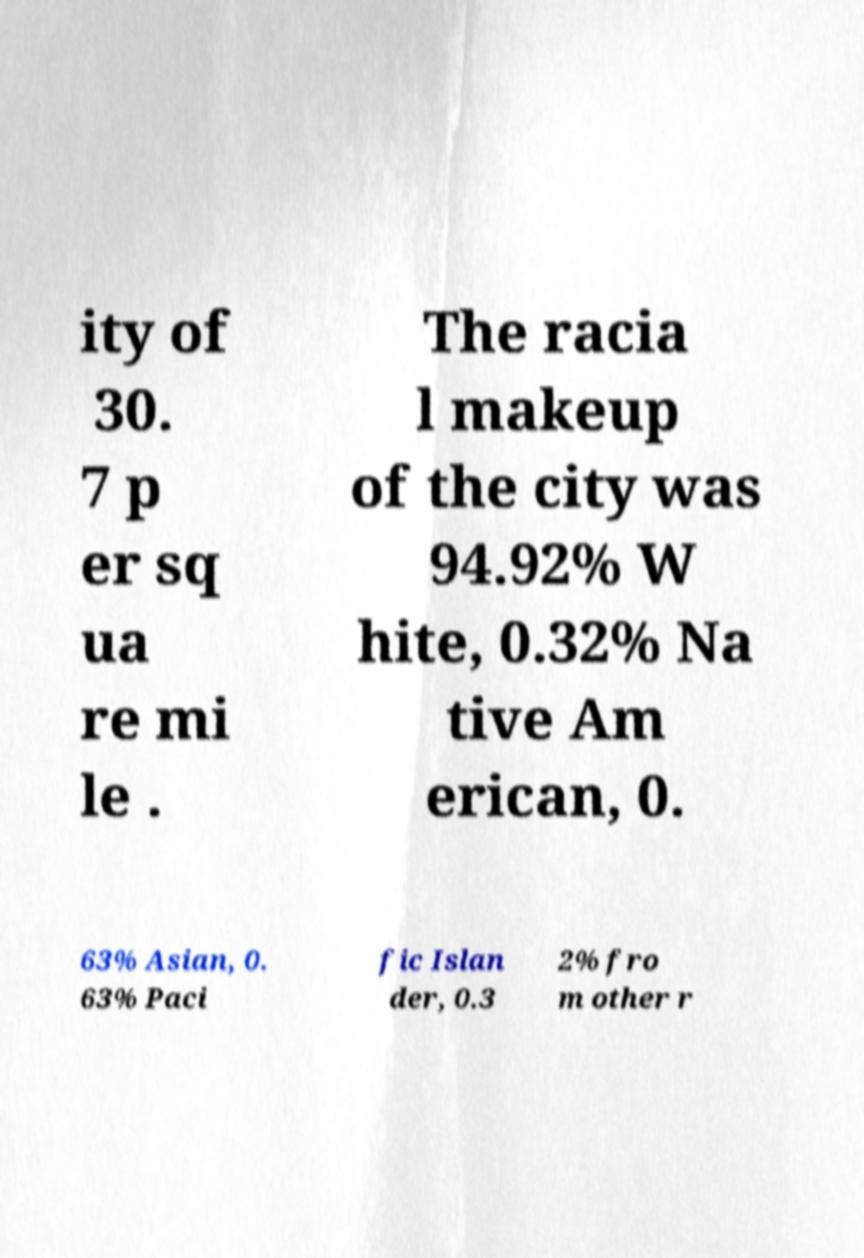Can you accurately transcribe the text from the provided image for me? ity of 30. 7 p er sq ua re mi le . The racia l makeup of the city was 94.92% W hite, 0.32% Na tive Am erican, 0. 63% Asian, 0. 63% Paci fic Islan der, 0.3 2% fro m other r 